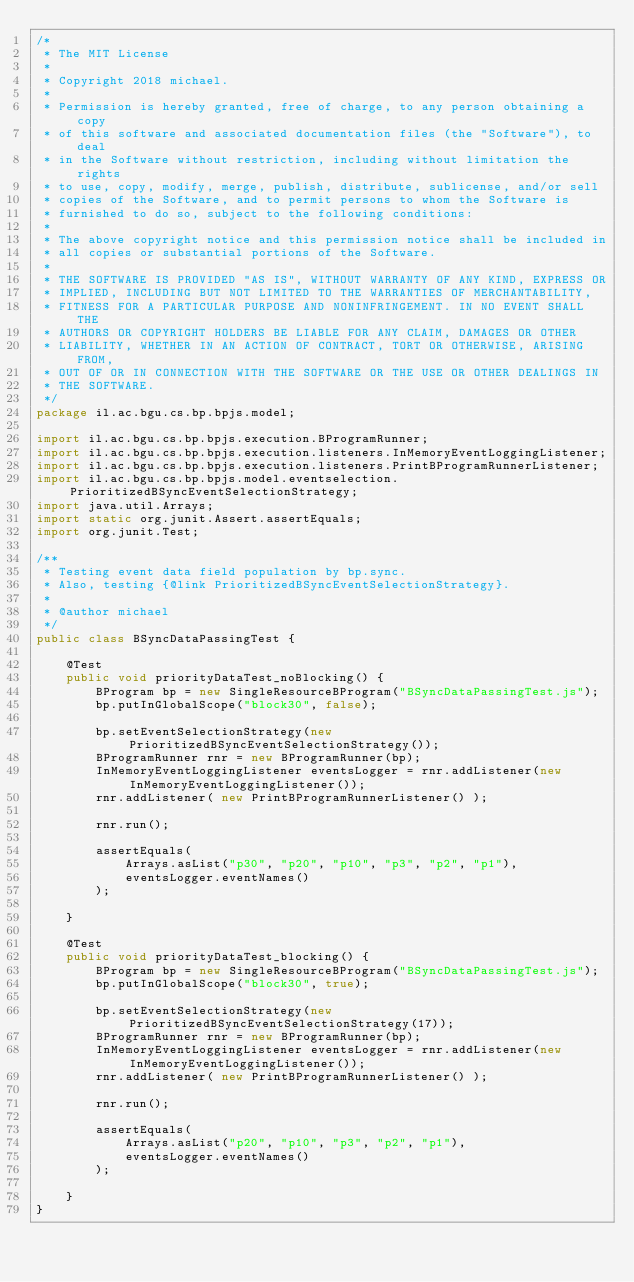Convert code to text. <code><loc_0><loc_0><loc_500><loc_500><_Java_>/*
 * The MIT License
 *
 * Copyright 2018 michael.
 *
 * Permission is hereby granted, free of charge, to any person obtaining a copy
 * of this software and associated documentation files (the "Software"), to deal
 * in the Software without restriction, including without limitation the rights
 * to use, copy, modify, merge, publish, distribute, sublicense, and/or sell
 * copies of the Software, and to permit persons to whom the Software is
 * furnished to do so, subject to the following conditions:
 *
 * The above copyright notice and this permission notice shall be included in
 * all copies or substantial portions of the Software.
 *
 * THE SOFTWARE IS PROVIDED "AS IS", WITHOUT WARRANTY OF ANY KIND, EXPRESS OR
 * IMPLIED, INCLUDING BUT NOT LIMITED TO THE WARRANTIES OF MERCHANTABILITY,
 * FITNESS FOR A PARTICULAR PURPOSE AND NONINFRINGEMENT. IN NO EVENT SHALL THE
 * AUTHORS OR COPYRIGHT HOLDERS BE LIABLE FOR ANY CLAIM, DAMAGES OR OTHER
 * LIABILITY, WHETHER IN AN ACTION OF CONTRACT, TORT OR OTHERWISE, ARISING FROM,
 * OUT OF OR IN CONNECTION WITH THE SOFTWARE OR THE USE OR OTHER DEALINGS IN
 * THE SOFTWARE.
 */
package il.ac.bgu.cs.bp.bpjs.model;

import il.ac.bgu.cs.bp.bpjs.execution.BProgramRunner;
import il.ac.bgu.cs.bp.bpjs.execution.listeners.InMemoryEventLoggingListener;
import il.ac.bgu.cs.bp.bpjs.execution.listeners.PrintBProgramRunnerListener;
import il.ac.bgu.cs.bp.bpjs.model.eventselection.PrioritizedBSyncEventSelectionStrategy;
import java.util.Arrays;
import static org.junit.Assert.assertEquals;
import org.junit.Test;

/**
 * Testing event data field population by bp.sync. 
 * Also, testing {@link PrioritizedBSyncEventSelectionStrategy}.
 * 
 * @author michael
 */
public class BSyncDataPassingTest {
    
    @Test
    public void priorityDataTest_noBlocking() {
        BProgram bp = new SingleResourceBProgram("BSyncDataPassingTest.js");
        bp.putInGlobalScope("block30", false);
        
        bp.setEventSelectionStrategy(new PrioritizedBSyncEventSelectionStrategy());
        BProgramRunner rnr = new BProgramRunner(bp);
        InMemoryEventLoggingListener eventsLogger = rnr.addListener(new InMemoryEventLoggingListener());
        rnr.addListener( new PrintBProgramRunnerListener() );
        
        rnr.run();
        
        assertEquals(
            Arrays.asList("p30", "p20", "p10", "p3", "p2", "p1"),
            eventsLogger.eventNames()
        );
        
    }
    
    @Test
    public void priorityDataTest_blocking() {
        BProgram bp = new SingleResourceBProgram("BSyncDataPassingTest.js");
        bp.putInGlobalScope("block30", true);
        
        bp.setEventSelectionStrategy(new PrioritizedBSyncEventSelectionStrategy(17));
        BProgramRunner rnr = new BProgramRunner(bp);
        InMemoryEventLoggingListener eventsLogger = rnr.addListener(new InMemoryEventLoggingListener());
        rnr.addListener( new PrintBProgramRunnerListener() );
        
        rnr.run();
        
        assertEquals(
            Arrays.asList("p20", "p10", "p3", "p2", "p1"),
            eventsLogger.eventNames()
        );
        
    }
}
</code> 